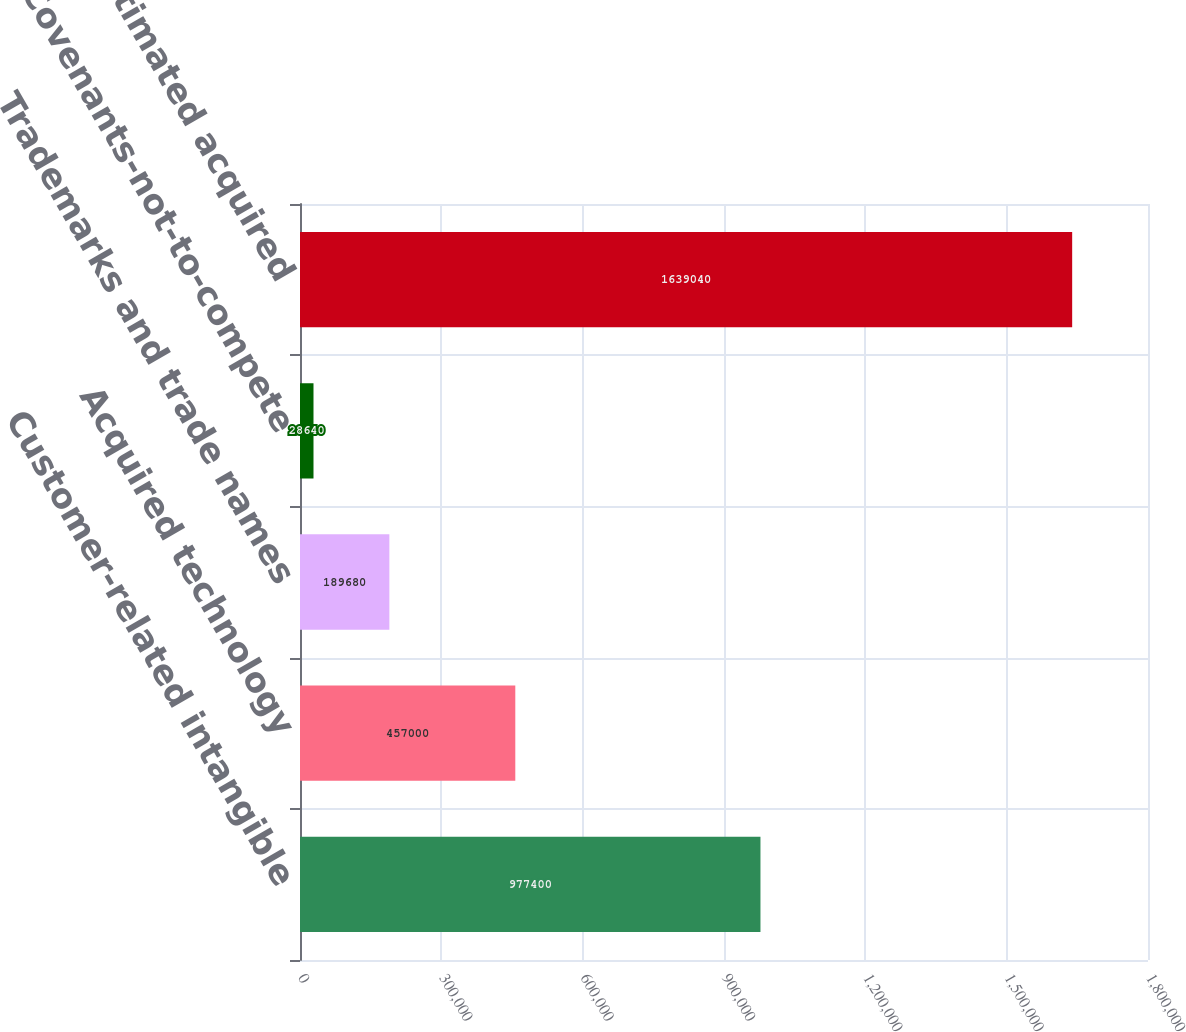Convert chart. <chart><loc_0><loc_0><loc_500><loc_500><bar_chart><fcel>Customer-related intangible<fcel>Acquired technology<fcel>Trademarks and trade names<fcel>Covenants-not-to-compete<fcel>Total estimated acquired<nl><fcel>977400<fcel>457000<fcel>189680<fcel>28640<fcel>1.63904e+06<nl></chart> 